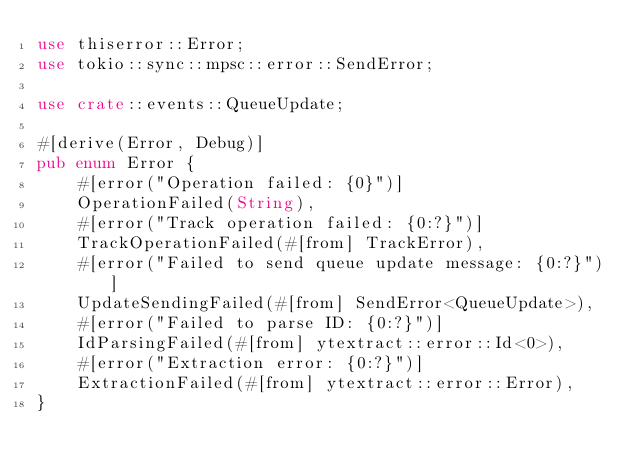<code> <loc_0><loc_0><loc_500><loc_500><_Rust_>use thiserror::Error;
use tokio::sync::mpsc::error::SendError;

use crate::events::QueueUpdate;

#[derive(Error, Debug)]
pub enum Error {
    #[error("Operation failed: {0}")]
    OperationFailed(String),
    #[error("Track operation failed: {0:?}")]
    TrackOperationFailed(#[from] TrackError),
    #[error("Failed to send queue update message: {0:?}")]
    UpdateSendingFailed(#[from] SendError<QueueUpdate>),
    #[error("Failed to parse ID: {0:?}")]
    IdParsingFailed(#[from] ytextract::error::Id<0>),
    #[error("Extraction error: {0:?}")]
    ExtractionFailed(#[from] ytextract::error::Error),
}
</code> 